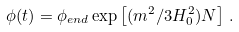<formula> <loc_0><loc_0><loc_500><loc_500>\phi ( t ) = \phi _ { e n d } \exp \left [ ( m ^ { 2 } / 3 H ^ { 2 } _ { 0 } ) N \right ] \, .</formula> 